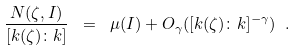Convert formula to latex. <formula><loc_0><loc_0><loc_500><loc_500>\frac { N ( \zeta , I ) } { [ k ( \zeta ) \colon k ] } \ = \ \mu ( I ) + O _ { \gamma } ( [ k ( \zeta ) \colon k ] ^ { - \gamma } ) \ .</formula> 